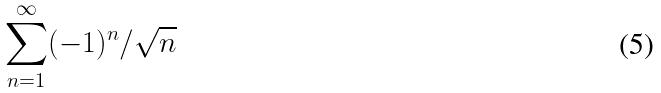Convert formula to latex. <formula><loc_0><loc_0><loc_500><loc_500>\sum _ { n = 1 } ^ { \infty } ( - 1 ) ^ { n } / \sqrt { n }</formula> 